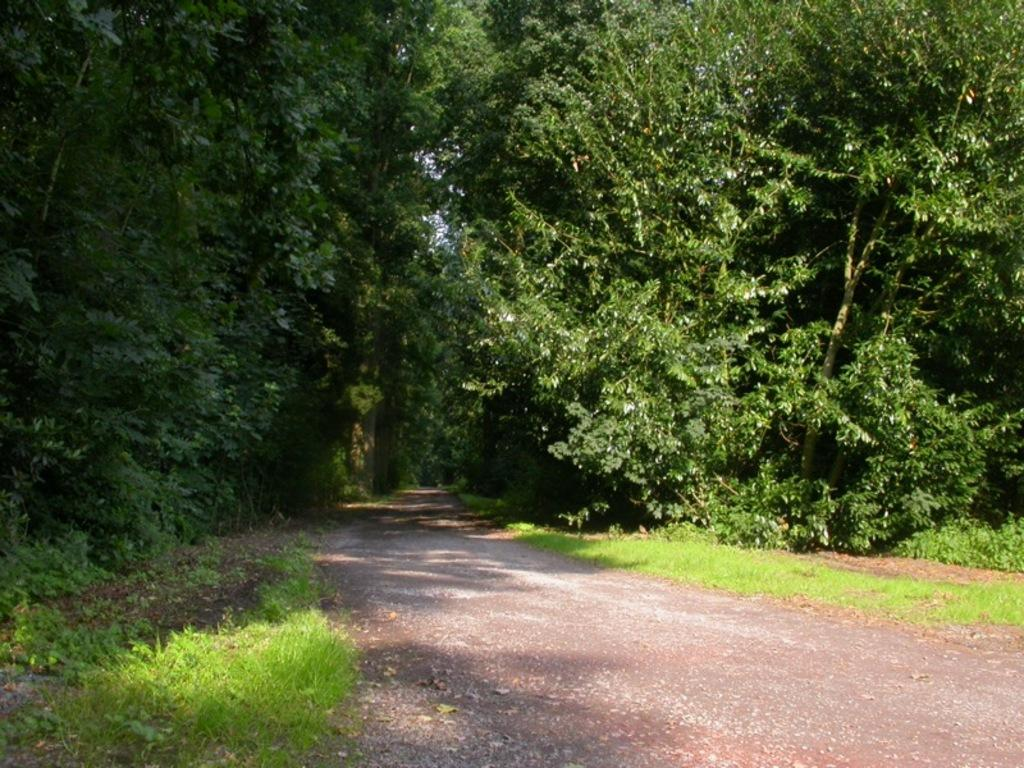What is the main subject of the image? The main subject of the image is a road. What can be seen on both sides of the road? Trees and grasslands are present on both sides of the road. What type of advice can be seen written on the trees in the image? There is no advice written on the trees in the image; the trees are simply part of the natural landscape. What scientific discoveries can be observed in the image? There are no scientific discoveries depicted in the image; it is a simple scene of a road with trees and grasslands. 